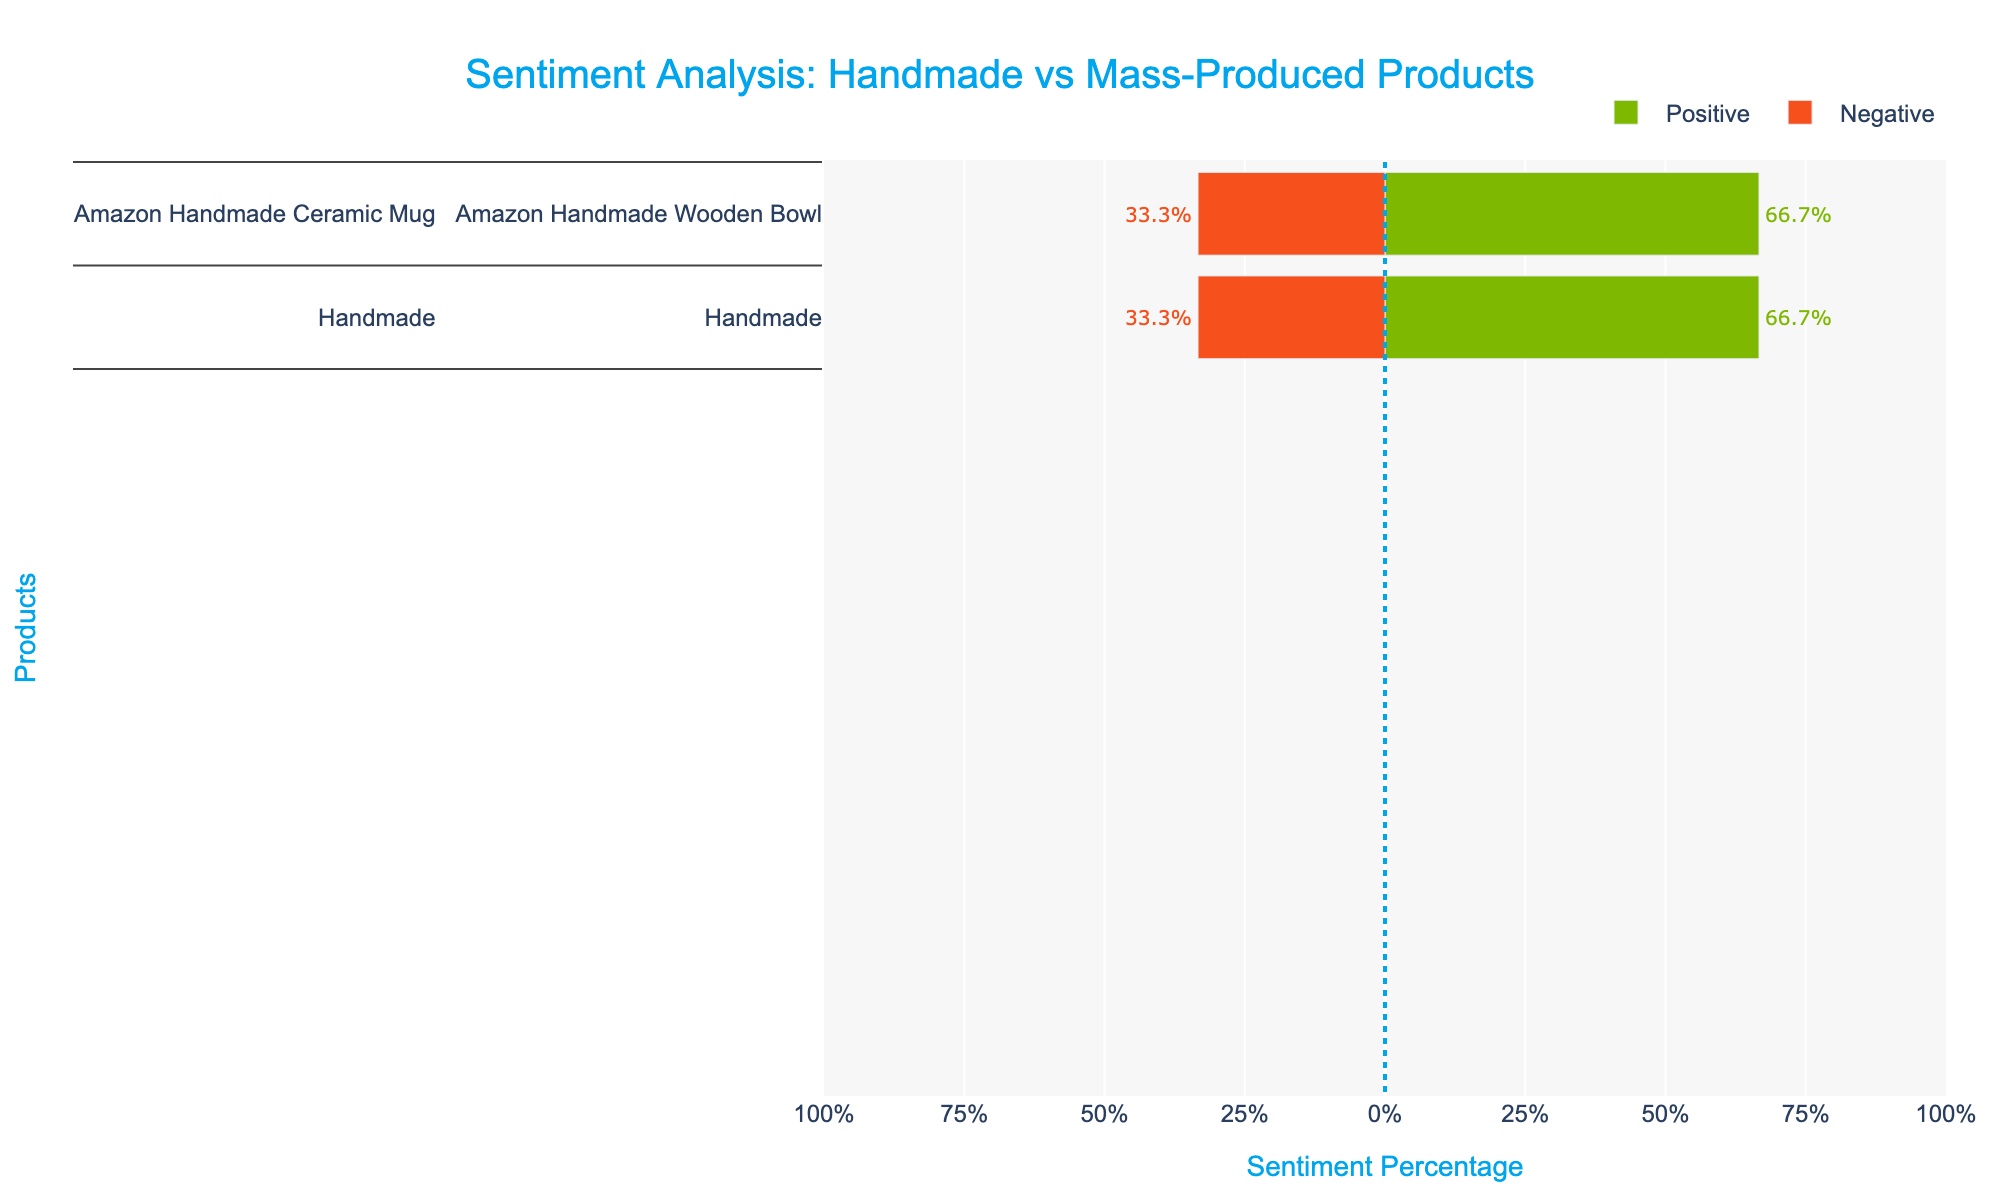What is the product with the highest positive review percentage? Identify the product with the longest green bar on the positive side (right side). This product is 'Etsy Knitted Scarf'.
Answer: Etsy Knitted Scarf Which mass-produced product has the highest percentage of negative reviews? Compare the lengths of the red bars on the negative side (left side) for mass-produced products. 'Walmart Polyester Blanket' has the longest red bar among mass-produced products.
Answer: Walmart Polyester Blanket What is the average percentage of positive reviews for handmade products? Calculate the positive percentages for handmade products (Etsy Embroidered Cushion: 66.7%, Amazon Handmade Wooden Bowl: 66.7%, Etsy Knitted Scarf: 66.7%, Amazon Handmade Ceramic Mug: 66.7%), then find their average: (66.7 + 66.7 + 66.7 + 66.7)/4.
Answer: 66.7% Which product has the smallest percentage of neutral reviews? Identify the shortest bar section of neutral reviews (gray color) on both sides. 'Ikea Glassware Set' and 'Walmart Polyester Blanket' have 0% neutral reviews.
Answer: Ikea Glassware Set and Walmart Polyester Blanket What is the total percentage of reviews (positive + negative) for Etsy Embroidered Cushion? Add the lengths of the positive (66.7%) and negative (-33.3%) bars for Etsy Embroidered Cushion. The absolute values are used in the sum: 66.7 + 33.3.
Answer: 100% Which products have an equal percentage of positive reviews? Identify products with equal lengths of green bars on the positive side. Etsy Embroidered Cushion, Amazon Handmade Wooden Bowl, Etsy Knitted Scarf, and Amazon Handmade Ceramic Mug each have 66.7% positive reviews.
Answer: Etsy Embroidered Cushion, Amazon Handmade Wooden Bowl, Etsy Knitted Scarf, and Amazon Handmade Ceramic Mug How does the negative review percentage of Target Throw Pillow compare to Ikea Glassware Set? Compare the red bar lengths on the negative side for both products. 'Target Throw Pillow': 50%, 'Ikea Glassware Set': 50%.
Answer: Equal What is the difference in positive review percentages between the product with the highest (Etsy Knitted Scarf) and lowest positive reviews (Target Throw Pillow)? The highest positive review percentage is Etsy Knitted Scarf at 66.7%, and the lowest is Target Throw Pillow at 50%. Calculate the difference: 66.7 - 50.
Answer: 16.7% 